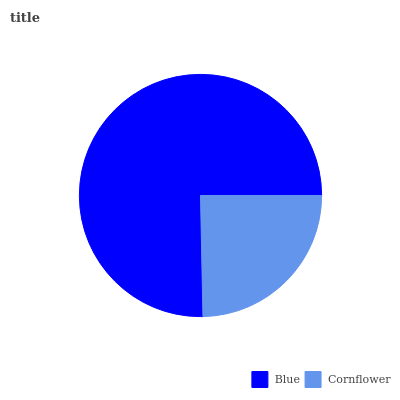Is Cornflower the minimum?
Answer yes or no. Yes. Is Blue the maximum?
Answer yes or no. Yes. Is Cornflower the maximum?
Answer yes or no. No. Is Blue greater than Cornflower?
Answer yes or no. Yes. Is Cornflower less than Blue?
Answer yes or no. Yes. Is Cornflower greater than Blue?
Answer yes or no. No. Is Blue less than Cornflower?
Answer yes or no. No. Is Blue the high median?
Answer yes or no. Yes. Is Cornflower the low median?
Answer yes or no. Yes. Is Cornflower the high median?
Answer yes or no. No. Is Blue the low median?
Answer yes or no. No. 